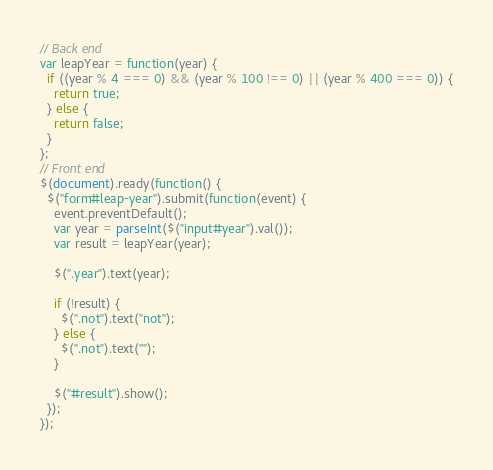Convert code to text. <code><loc_0><loc_0><loc_500><loc_500><_JavaScript_>// Back end
var leapYear = function(year) {
  if ((year % 4 === 0) && (year % 100 !== 0) || (year % 400 === 0)) {
    return true;
  } else {
    return false;
  }
};
// Front end
$(document).ready(function() {
  $("form#leap-year").submit(function(event) {
    event.preventDefault();
    var year = parseInt($("input#year").val());
    var result = leapYear(year);

    $(".year").text(year);

    if (!result) {
      $(".not").text("not");
    } else {
      $(".not").text("");
    }
    
    $("#result").show();
  });
});
</code> 